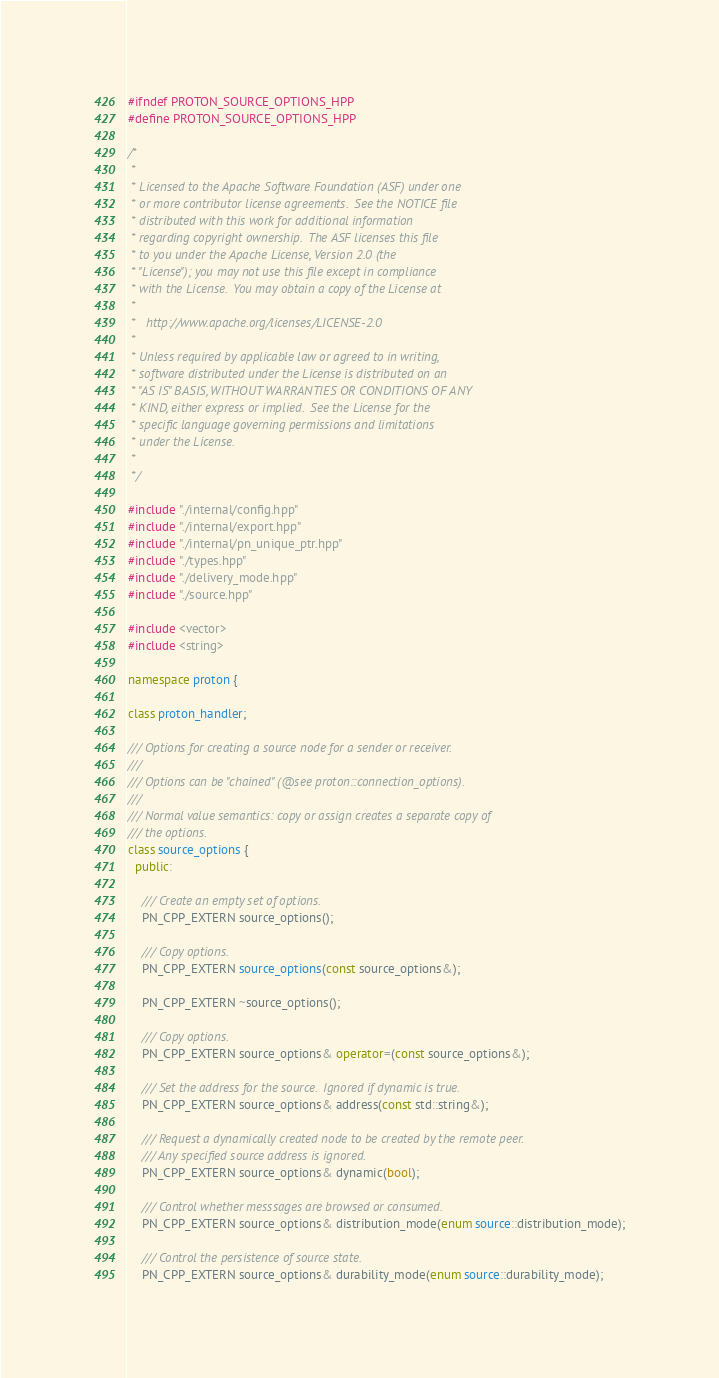Convert code to text. <code><loc_0><loc_0><loc_500><loc_500><_C++_>#ifndef PROTON_SOURCE_OPTIONS_HPP
#define PROTON_SOURCE_OPTIONS_HPP

/*
 *
 * Licensed to the Apache Software Foundation (ASF) under one
 * or more contributor license agreements.  See the NOTICE file
 * distributed with this work for additional information
 * regarding copyright ownership.  The ASF licenses this file
 * to you under the Apache License, Version 2.0 (the
 * "License"); you may not use this file except in compliance
 * with the License.  You may obtain a copy of the License at
 *
 *   http://www.apache.org/licenses/LICENSE-2.0
 *
 * Unless required by applicable law or agreed to in writing,
 * software distributed under the License is distributed on an
 * "AS IS" BASIS, WITHOUT WARRANTIES OR CONDITIONS OF ANY
 * KIND, either express or implied.  See the License for the
 * specific language governing permissions and limitations
 * under the License.
 *
 */

#include "./internal/config.hpp"
#include "./internal/export.hpp"
#include "./internal/pn_unique_ptr.hpp"
#include "./types.hpp"
#include "./delivery_mode.hpp"
#include "./source.hpp"

#include <vector>
#include <string>

namespace proton {

class proton_handler;

/// Options for creating a source node for a sender or receiver.
///
/// Options can be "chained" (@see proton::connection_options).
///
/// Normal value semantics: copy or assign creates a separate copy of
/// the options.
class source_options {
  public:

    /// Create an empty set of options.
    PN_CPP_EXTERN source_options();

    /// Copy options.
    PN_CPP_EXTERN source_options(const source_options&);

    PN_CPP_EXTERN ~source_options();

    /// Copy options.
    PN_CPP_EXTERN source_options& operator=(const source_options&);

    /// Set the address for the source.  Ignored if dynamic is true.
    PN_CPP_EXTERN source_options& address(const std::string&);

    /// Request a dynamically created node to be created by the remote peer.
    /// Any specified source address is ignored.
    PN_CPP_EXTERN source_options& dynamic(bool);

    /// Control whether messsages are browsed or consumed.
    PN_CPP_EXTERN source_options& distribution_mode(enum source::distribution_mode);

    /// Control the persistence of source state.
    PN_CPP_EXTERN source_options& durability_mode(enum source::durability_mode);
</code> 